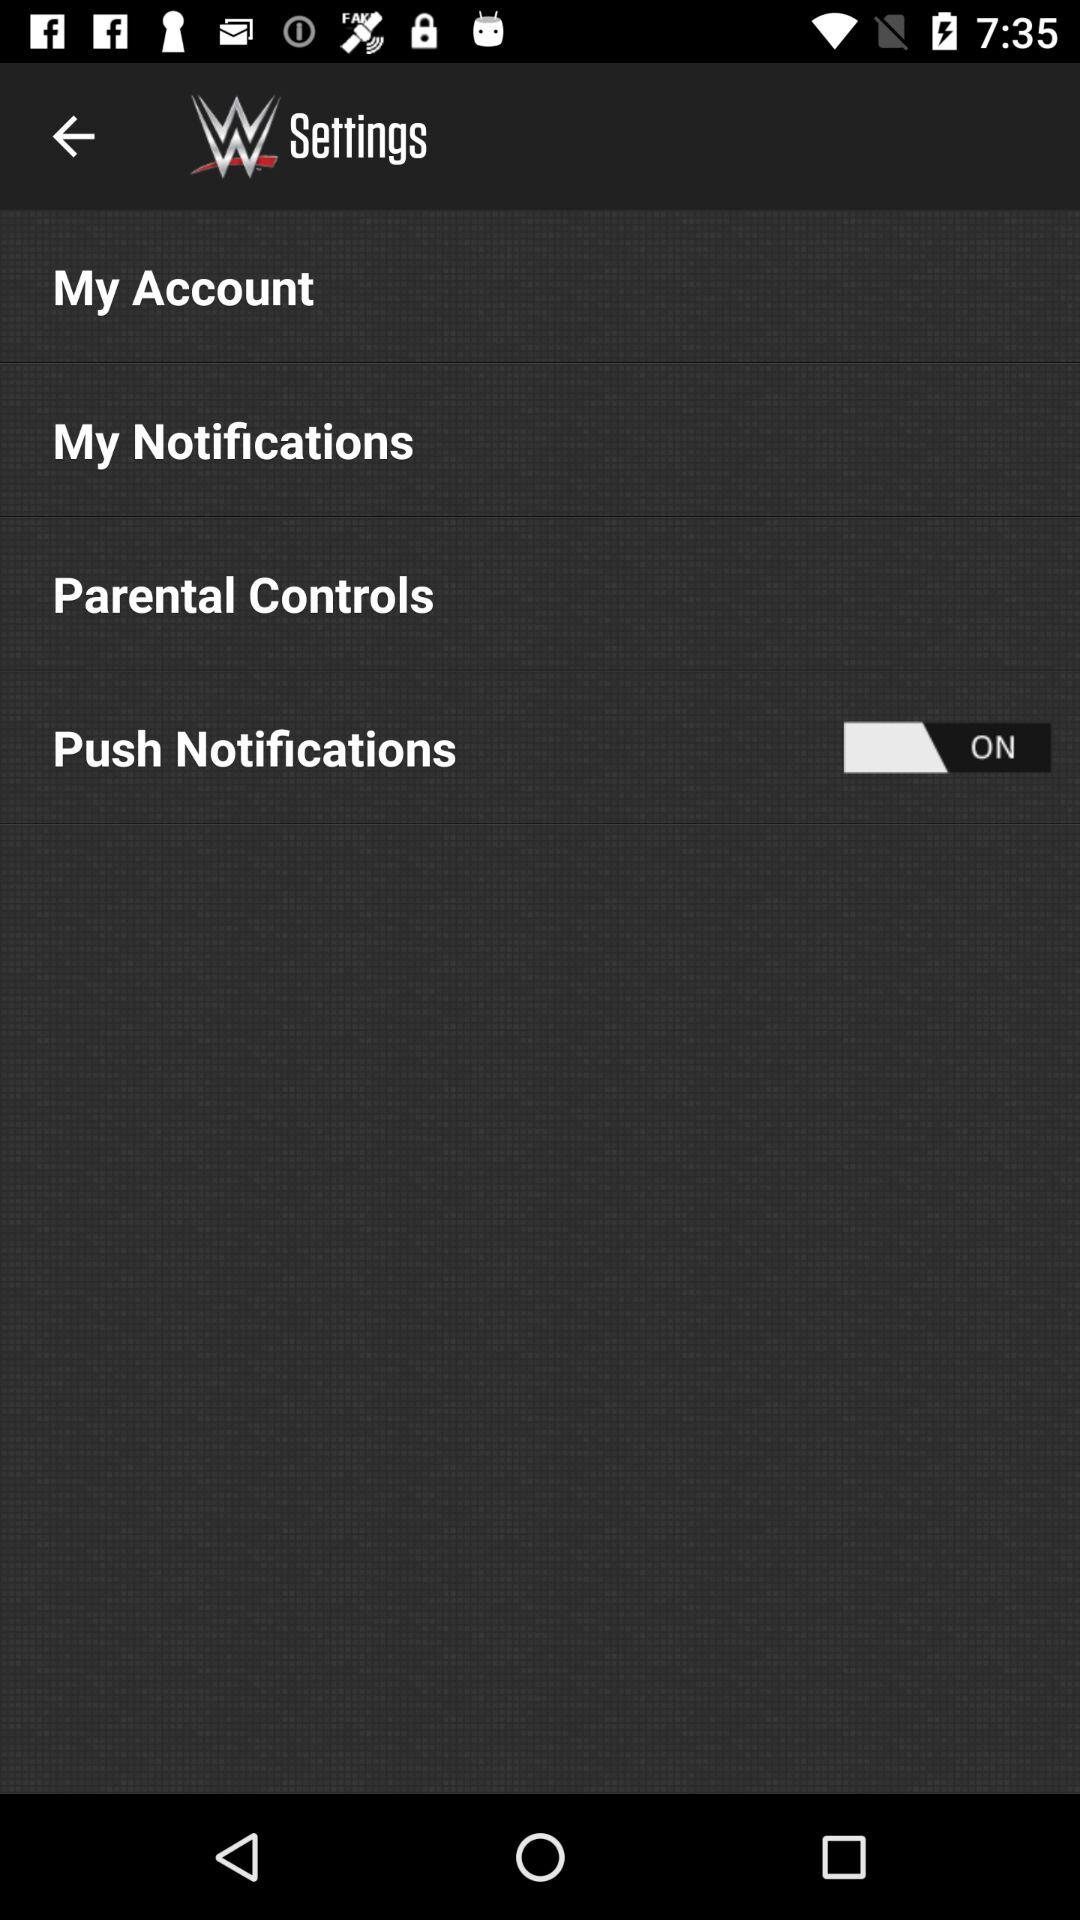Which parameters are set in the parental controls?
When the provided information is insufficient, respond with <no answer>. <no answer> 